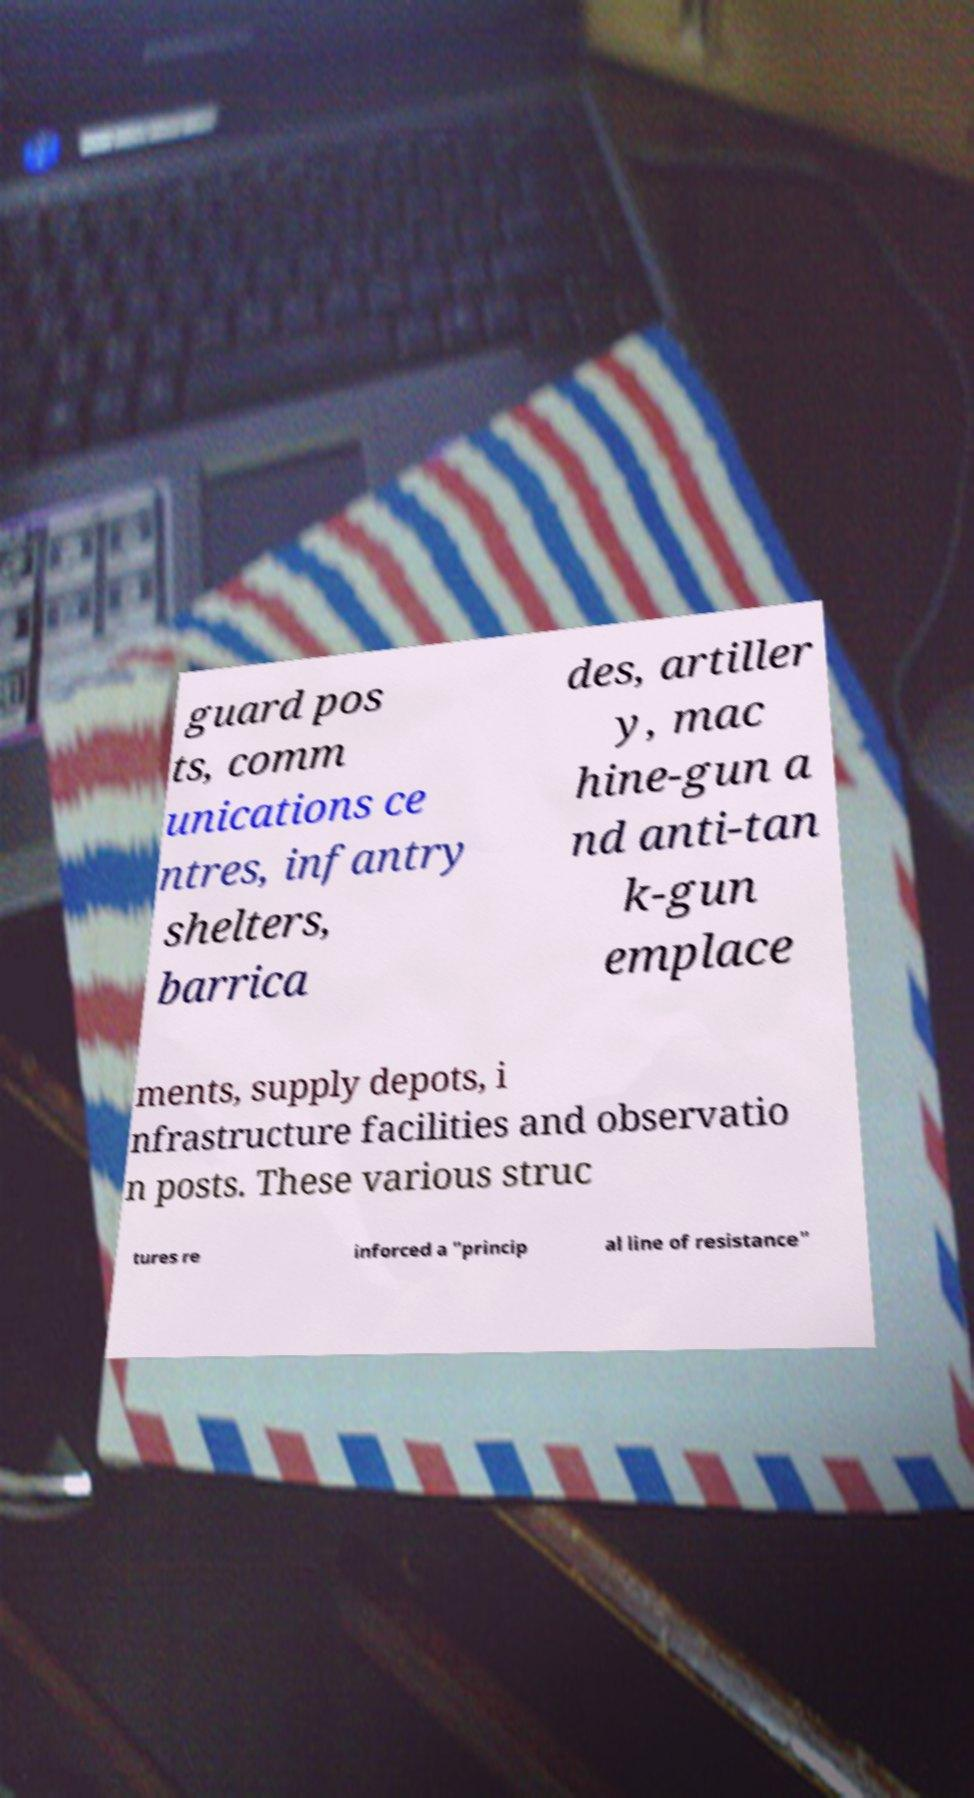There's text embedded in this image that I need extracted. Can you transcribe it verbatim? guard pos ts, comm unications ce ntres, infantry shelters, barrica des, artiller y, mac hine-gun a nd anti-tan k-gun emplace ments, supply depots, i nfrastructure facilities and observatio n posts. These various struc tures re inforced a "princip al line of resistance" 